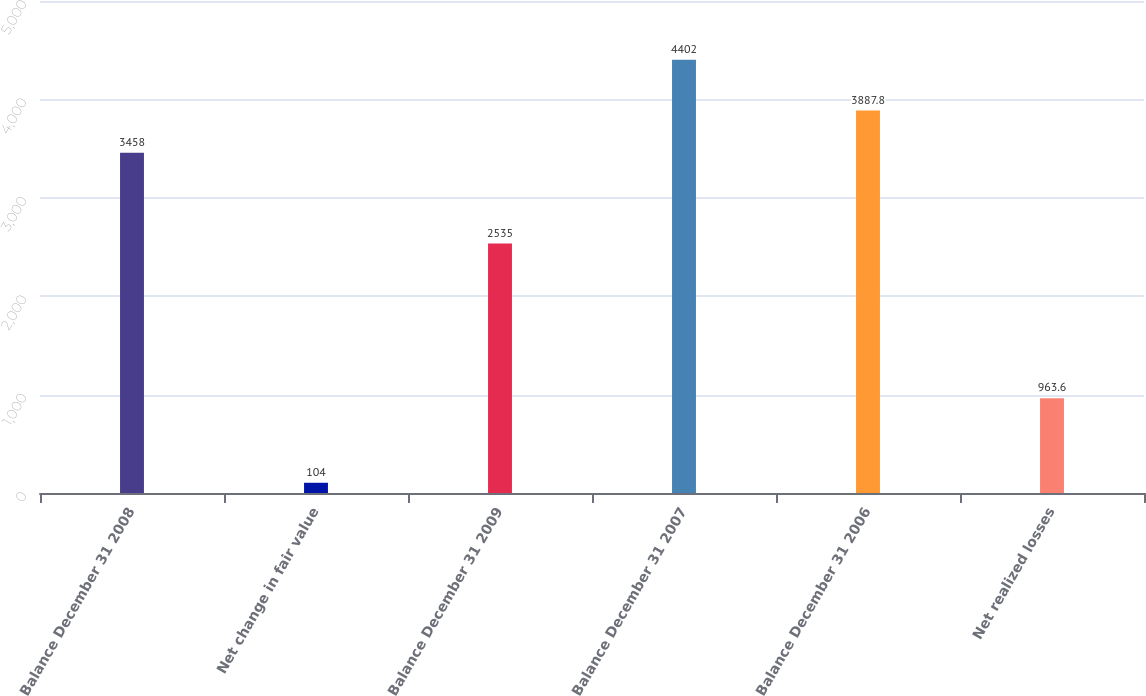Convert chart to OTSL. <chart><loc_0><loc_0><loc_500><loc_500><bar_chart><fcel>Balance December 31 2008<fcel>Net change in fair value<fcel>Balance December 31 2009<fcel>Balance December 31 2007<fcel>Balance December 31 2006<fcel>Net realized losses<nl><fcel>3458<fcel>104<fcel>2535<fcel>4402<fcel>3887.8<fcel>963.6<nl></chart> 